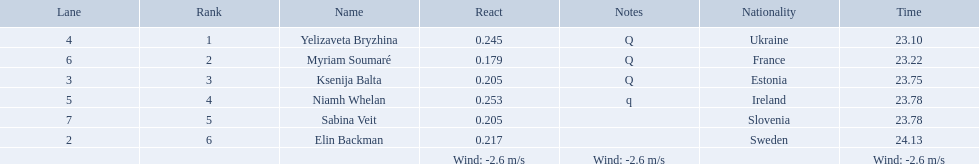What are all the names? Yelizaveta Bryzhina, Myriam Soumaré, Ksenija Balta, Niamh Whelan, Sabina Veit, Elin Backman. What were their finishing times? 23.10, 23.22, 23.75, 23.78, 23.78, 24.13. And which time was reached by ellen backman? 24.13. Which athlete is from sweden? Elin Backman. What was their time to finish the race? 24.13. 